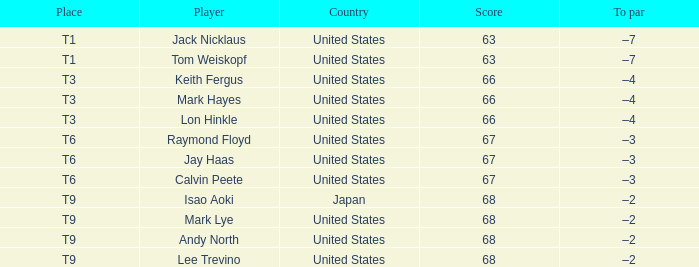What is the Country, when Place is T6, and when Player is "Raymond Floyd"? United States. 